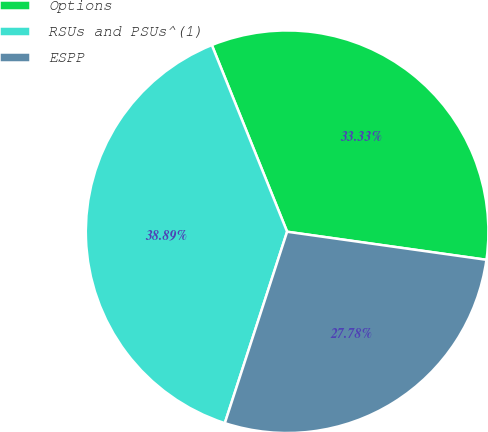Convert chart to OTSL. <chart><loc_0><loc_0><loc_500><loc_500><pie_chart><fcel>Options<fcel>RSUs and PSUs^(1)<fcel>ESPP<nl><fcel>33.33%<fcel>38.89%<fcel>27.78%<nl></chart> 